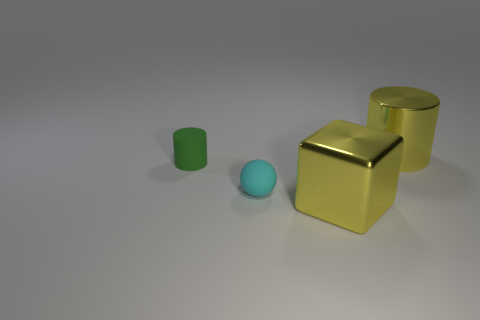Add 4 tiny green cylinders. How many objects exist? 8 Subtract all blocks. How many objects are left? 3 Add 2 big things. How many big things exist? 4 Subtract 0 cyan cylinders. How many objects are left? 4 Subtract all green matte things. Subtract all big metallic objects. How many objects are left? 1 Add 2 big metal blocks. How many big metal blocks are left? 3 